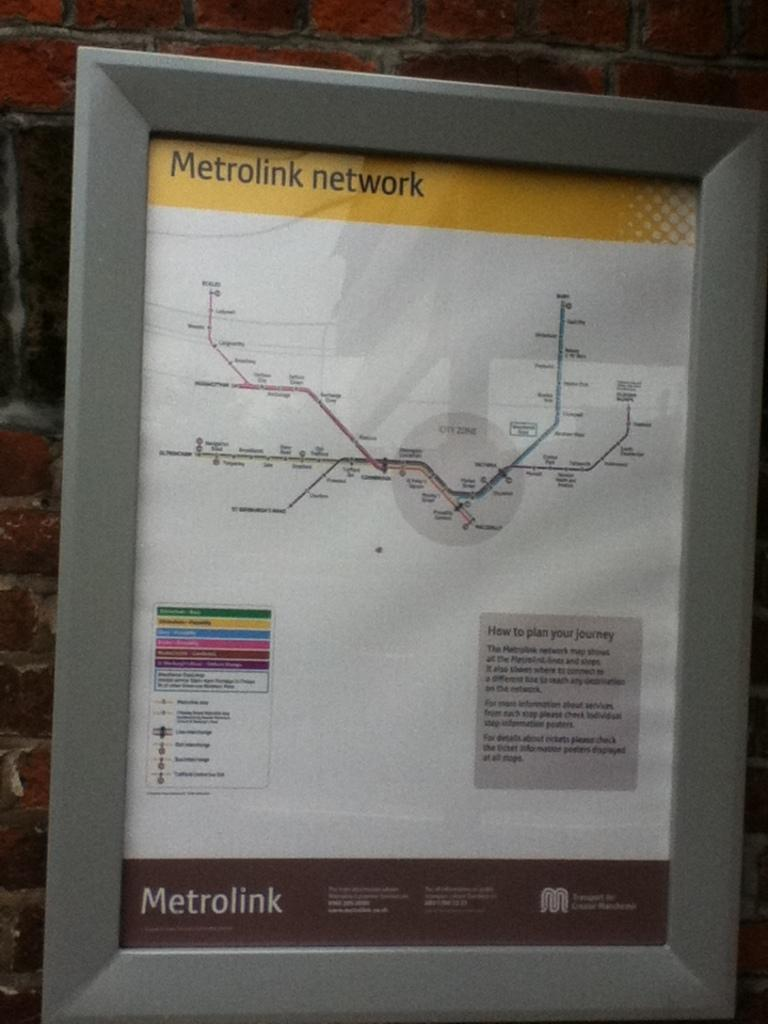<image>
Write a terse but informative summary of the picture. A Metrolink sign in a frame hangs on a brick wall 